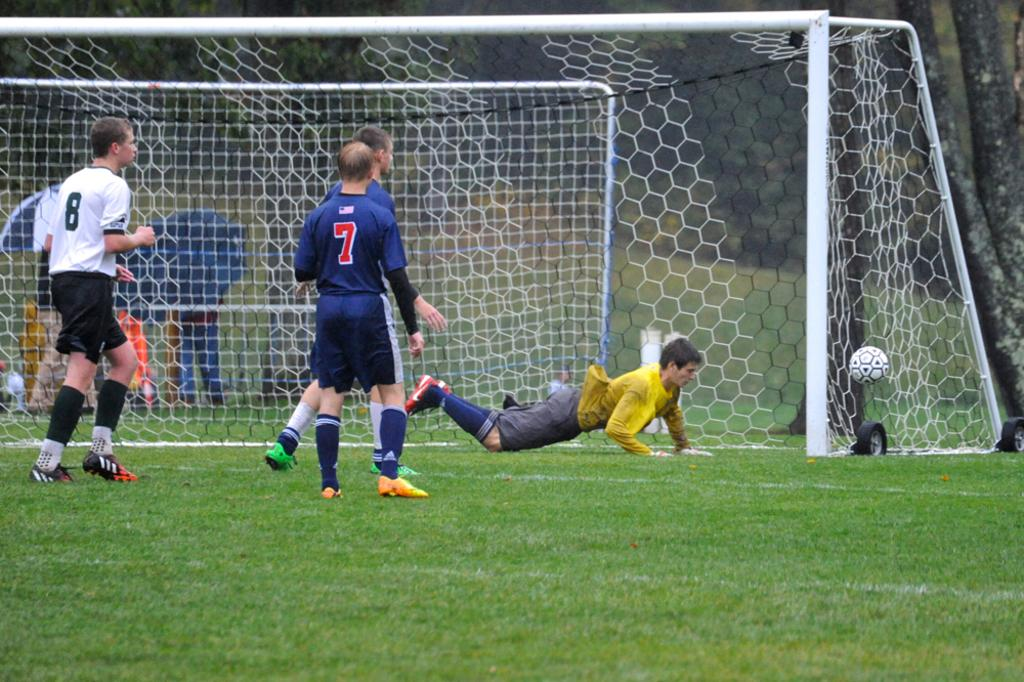What are the people in the image doing? The players in the image are playing football. Where are the players located? The players are on a football ground. What can be seen in the background of the image? There is a goal post in the background of the image. What type of addition problem can be solved using the players in the image? There is no addition problem present in the image, as it features players playing football on a football ground. Can you provide an example of a yam being used in the image? There is no yam present in the image; it features players playing football on a football ground. 